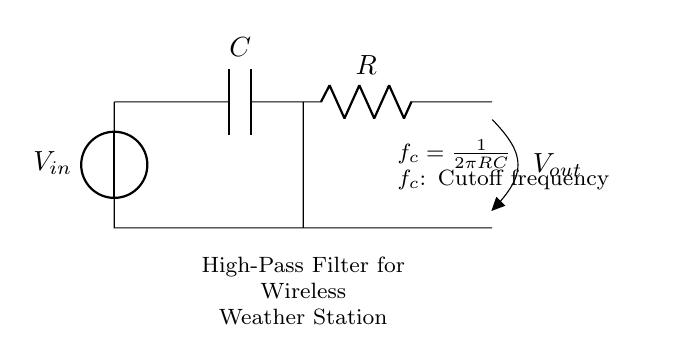What is the cutoff frequency formula in this circuit? The cutoff frequency formula is provided in the text near the circuit diagram. It is expressed as \( f_c = \frac{1}{2\pi RC} \), which indicates how the cutoff frequency depends on the resistance and capacitance values.
Answer: f_c = 1/2πRC What components are used in this high-pass filter? The circuit diagram shows a capacitor (C) and a resistor (R) as the key components of the high-pass filter. These components are critical in determining the filtering characteristics.
Answer: Capacitor and Resistor What type of filter is represented in this circuit? The diagram explicitly states that it is a high-pass filter, which allows frequencies higher than the cutoff frequency to pass while attenuating lower frequencies.
Answer: High-pass filter What happens to the output voltage for frequencies below the cutoff frequency? For frequencies below the cutoff frequency, the output voltage would be significantly reduced because the high-pass filter attenuates these lower frequencies, making them not effectively transmitted to the output.
Answer: Reduced What is the function of the capacitor in this circuit? The capacitor in this high-pass filter serves to block low-frequency signals while allowing high-frequency signals to pass through to the output. This characteristic is fundamental to the operation of the filter.
Answer: Blocks low frequencies What is the role of the resistor in this high-pass filter? The resistor in the circuit together with the capacitor defines the time constant and, therefore, the cutoff frequency of the high-pass filter, impacting the filtering performance of the circuit.
Answer: Defines time constant 